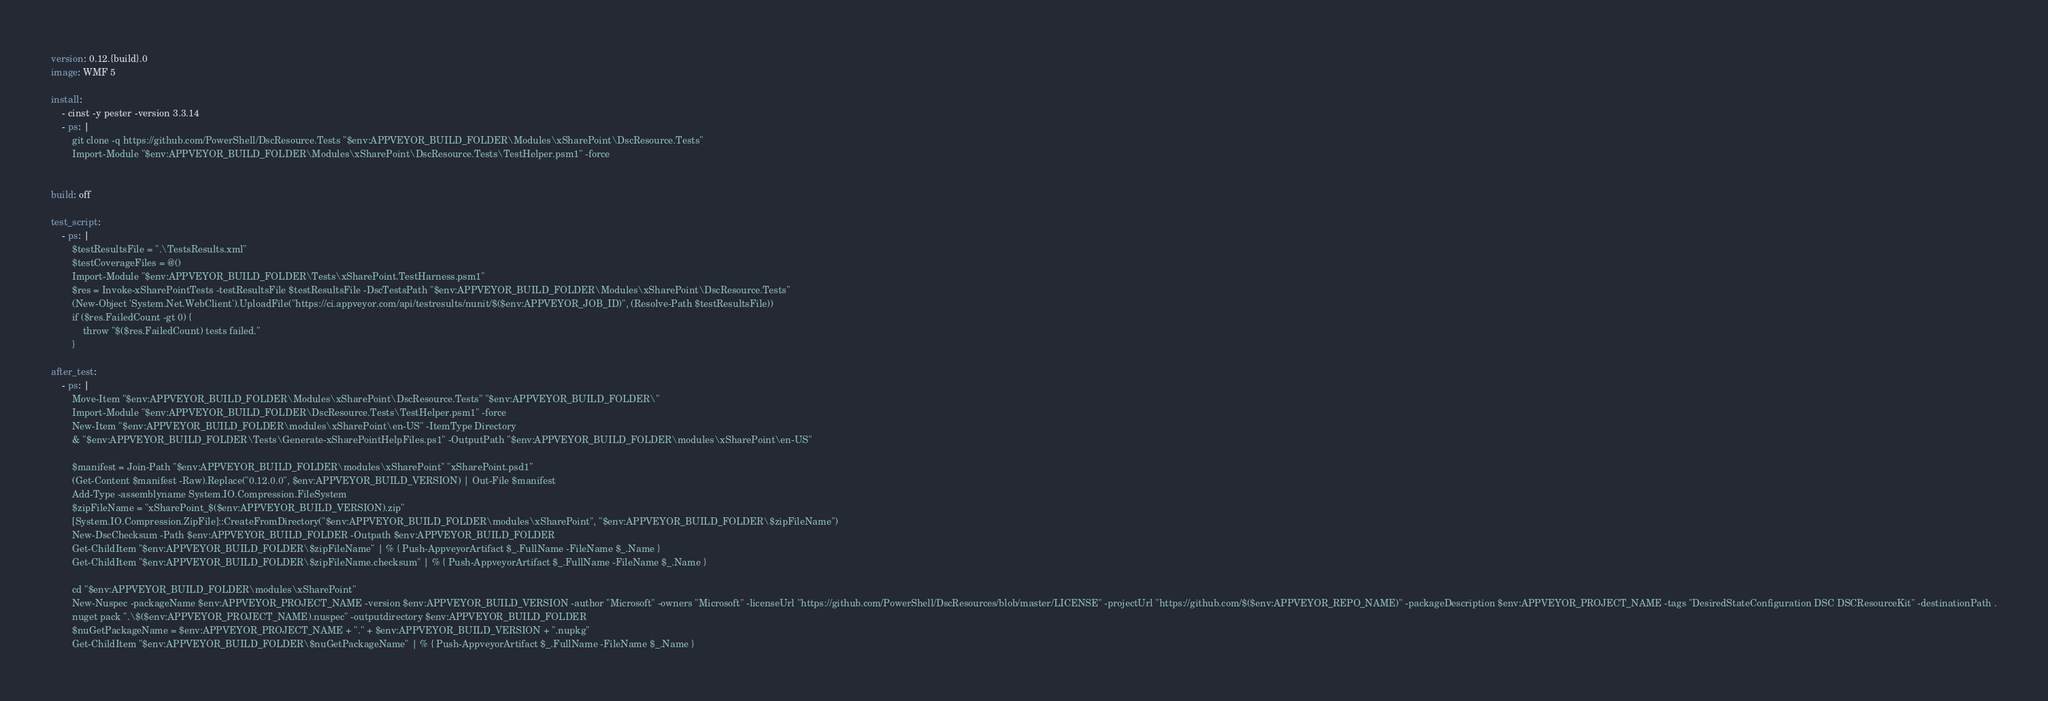<code> <loc_0><loc_0><loc_500><loc_500><_YAML_>version: 0.12.{build}.0
image: WMF 5

install:
    - cinst -y pester -version 3.3.14  
    - ps: |
        git clone -q https://github.com/PowerShell/DscResource.Tests "$env:APPVEYOR_BUILD_FOLDER\Modules\xSharePoint\DscResource.Tests"
        Import-Module "$env:APPVEYOR_BUILD_FOLDER\Modules\xSharePoint\DscResource.Tests\TestHelper.psm1" -force
        

build: off

test_script:
    - ps: |
        $testResultsFile = ".\TestsResults.xml"
        $testCoverageFiles = @()
        Import-Module "$env:APPVEYOR_BUILD_FOLDER\Tests\xSharePoint.TestHarness.psm1"
        $res = Invoke-xSharePointTests -testResultsFile $testResultsFile -DscTestsPath "$env:APPVEYOR_BUILD_FOLDER\Modules\xSharePoint\DscResource.Tests"
        (New-Object 'System.Net.WebClient').UploadFile("https://ci.appveyor.com/api/testresults/nunit/$($env:APPVEYOR_JOB_ID)", (Resolve-Path $testResultsFile))
        if ($res.FailedCount -gt 0) { 
            throw "$($res.FailedCount) tests failed."
        }

after_test:
    - ps: |
        Move-Item "$env:APPVEYOR_BUILD_FOLDER\Modules\xSharePoint\DscResource.Tests" "$env:APPVEYOR_BUILD_FOLDER\"
        Import-Module "$env:APPVEYOR_BUILD_FOLDER\DscResource.Tests\TestHelper.psm1" -force
        New-Item "$env:APPVEYOR_BUILD_FOLDER\modules\xSharePoint\en-US" -ItemType Directory
        & "$env:APPVEYOR_BUILD_FOLDER\Tests\Generate-xSharePointHelpFiles.ps1" -OutputPath "$env:APPVEYOR_BUILD_FOLDER\modules\xSharePoint\en-US"

        $manifest = Join-Path "$env:APPVEYOR_BUILD_FOLDER\modules\xSharePoint" "xSharePoint.psd1"
        (Get-Content $manifest -Raw).Replace("0.12.0.0", $env:APPVEYOR_BUILD_VERSION) | Out-File $manifest
        Add-Type -assemblyname System.IO.Compression.FileSystem
        $zipFileName = "xSharePoint_$($env:APPVEYOR_BUILD_VERSION).zip"
        [System.IO.Compression.ZipFile]::CreateFromDirectory("$env:APPVEYOR_BUILD_FOLDER\modules\xSharePoint", "$env:APPVEYOR_BUILD_FOLDER\$zipFileName")
        New-DscChecksum -Path $env:APPVEYOR_BUILD_FOLDER -Outpath $env:APPVEYOR_BUILD_FOLDER
        Get-ChildItem "$env:APPVEYOR_BUILD_FOLDER\$zipFileName" | % { Push-AppveyorArtifact $_.FullName -FileName $_.Name }
        Get-ChildItem "$env:APPVEYOR_BUILD_FOLDER\$zipFileName.checksum" | % { Push-AppveyorArtifact $_.FullName -FileName $_.Name }
        
        cd "$env:APPVEYOR_BUILD_FOLDER\modules\xSharePoint"
        New-Nuspec -packageName $env:APPVEYOR_PROJECT_NAME -version $env:APPVEYOR_BUILD_VERSION -author "Microsoft" -owners "Microsoft" -licenseUrl "https://github.com/PowerShell/DscResources/blob/master/LICENSE" -projectUrl "https://github.com/$($env:APPVEYOR_REPO_NAME)" -packageDescription $env:APPVEYOR_PROJECT_NAME -tags "DesiredStateConfiguration DSC DSCResourceKit" -destinationPath .
        nuget pack ".\$($env:APPVEYOR_PROJECT_NAME).nuspec" -outputdirectory $env:APPVEYOR_BUILD_FOLDER
        $nuGetPackageName = $env:APPVEYOR_PROJECT_NAME + "." + $env:APPVEYOR_BUILD_VERSION + ".nupkg"
        Get-ChildItem "$env:APPVEYOR_BUILD_FOLDER\$nuGetPackageName" | % { Push-AppveyorArtifact $_.FullName -FileName $_.Name }
</code> 